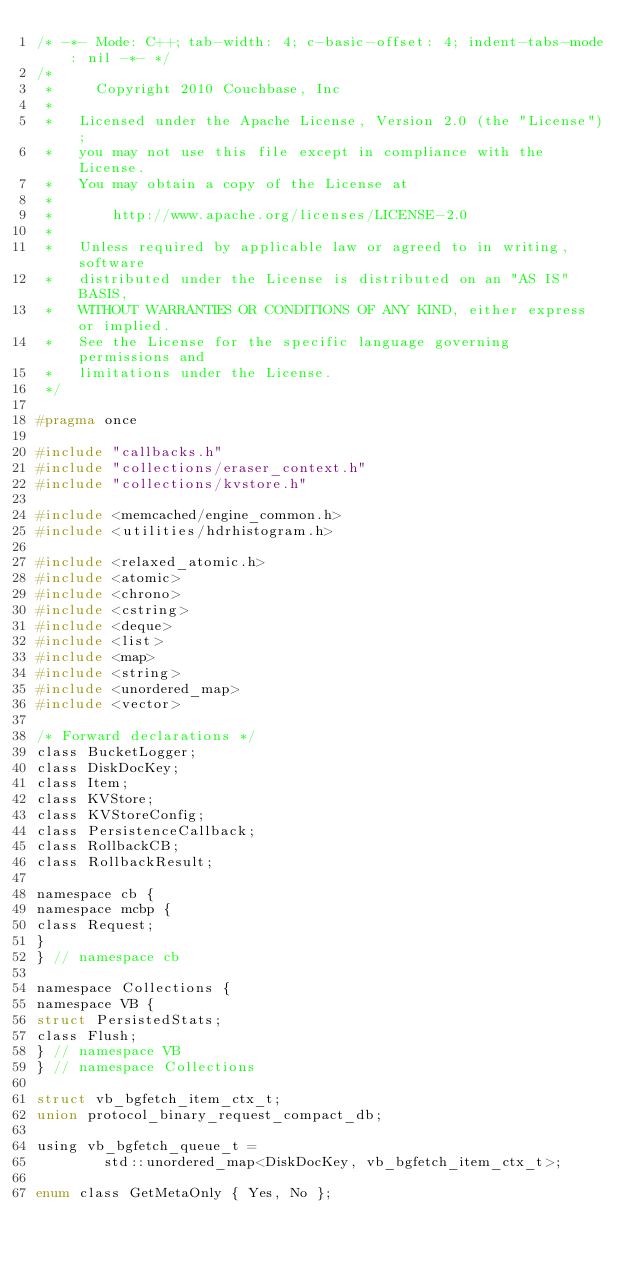<code> <loc_0><loc_0><loc_500><loc_500><_C_>/* -*- Mode: C++; tab-width: 4; c-basic-offset: 4; indent-tabs-mode: nil -*- */
/*
 *     Copyright 2010 Couchbase, Inc
 *
 *   Licensed under the Apache License, Version 2.0 (the "License");
 *   you may not use this file except in compliance with the License.
 *   You may obtain a copy of the License at
 *
 *       http://www.apache.org/licenses/LICENSE-2.0
 *
 *   Unless required by applicable law or agreed to in writing, software
 *   distributed under the License is distributed on an "AS IS" BASIS,
 *   WITHOUT WARRANTIES OR CONDITIONS OF ANY KIND, either express or implied.
 *   See the License for the specific language governing permissions and
 *   limitations under the License.
 */

#pragma once

#include "callbacks.h"
#include "collections/eraser_context.h"
#include "collections/kvstore.h"

#include <memcached/engine_common.h>
#include <utilities/hdrhistogram.h>

#include <relaxed_atomic.h>
#include <atomic>
#include <chrono>
#include <cstring>
#include <deque>
#include <list>
#include <map>
#include <string>
#include <unordered_map>
#include <vector>

/* Forward declarations */
class BucketLogger;
class DiskDocKey;
class Item;
class KVStore;
class KVStoreConfig;
class PersistenceCallback;
class RollbackCB;
class RollbackResult;

namespace cb {
namespace mcbp {
class Request;
}
} // namespace cb

namespace Collections {
namespace VB {
struct PersistedStats;
class Flush;
} // namespace VB
} // namespace Collections

struct vb_bgfetch_item_ctx_t;
union protocol_binary_request_compact_db;

using vb_bgfetch_queue_t =
        std::unordered_map<DiskDocKey, vb_bgfetch_item_ctx_t>;

enum class GetMetaOnly { Yes, No };
</code> 